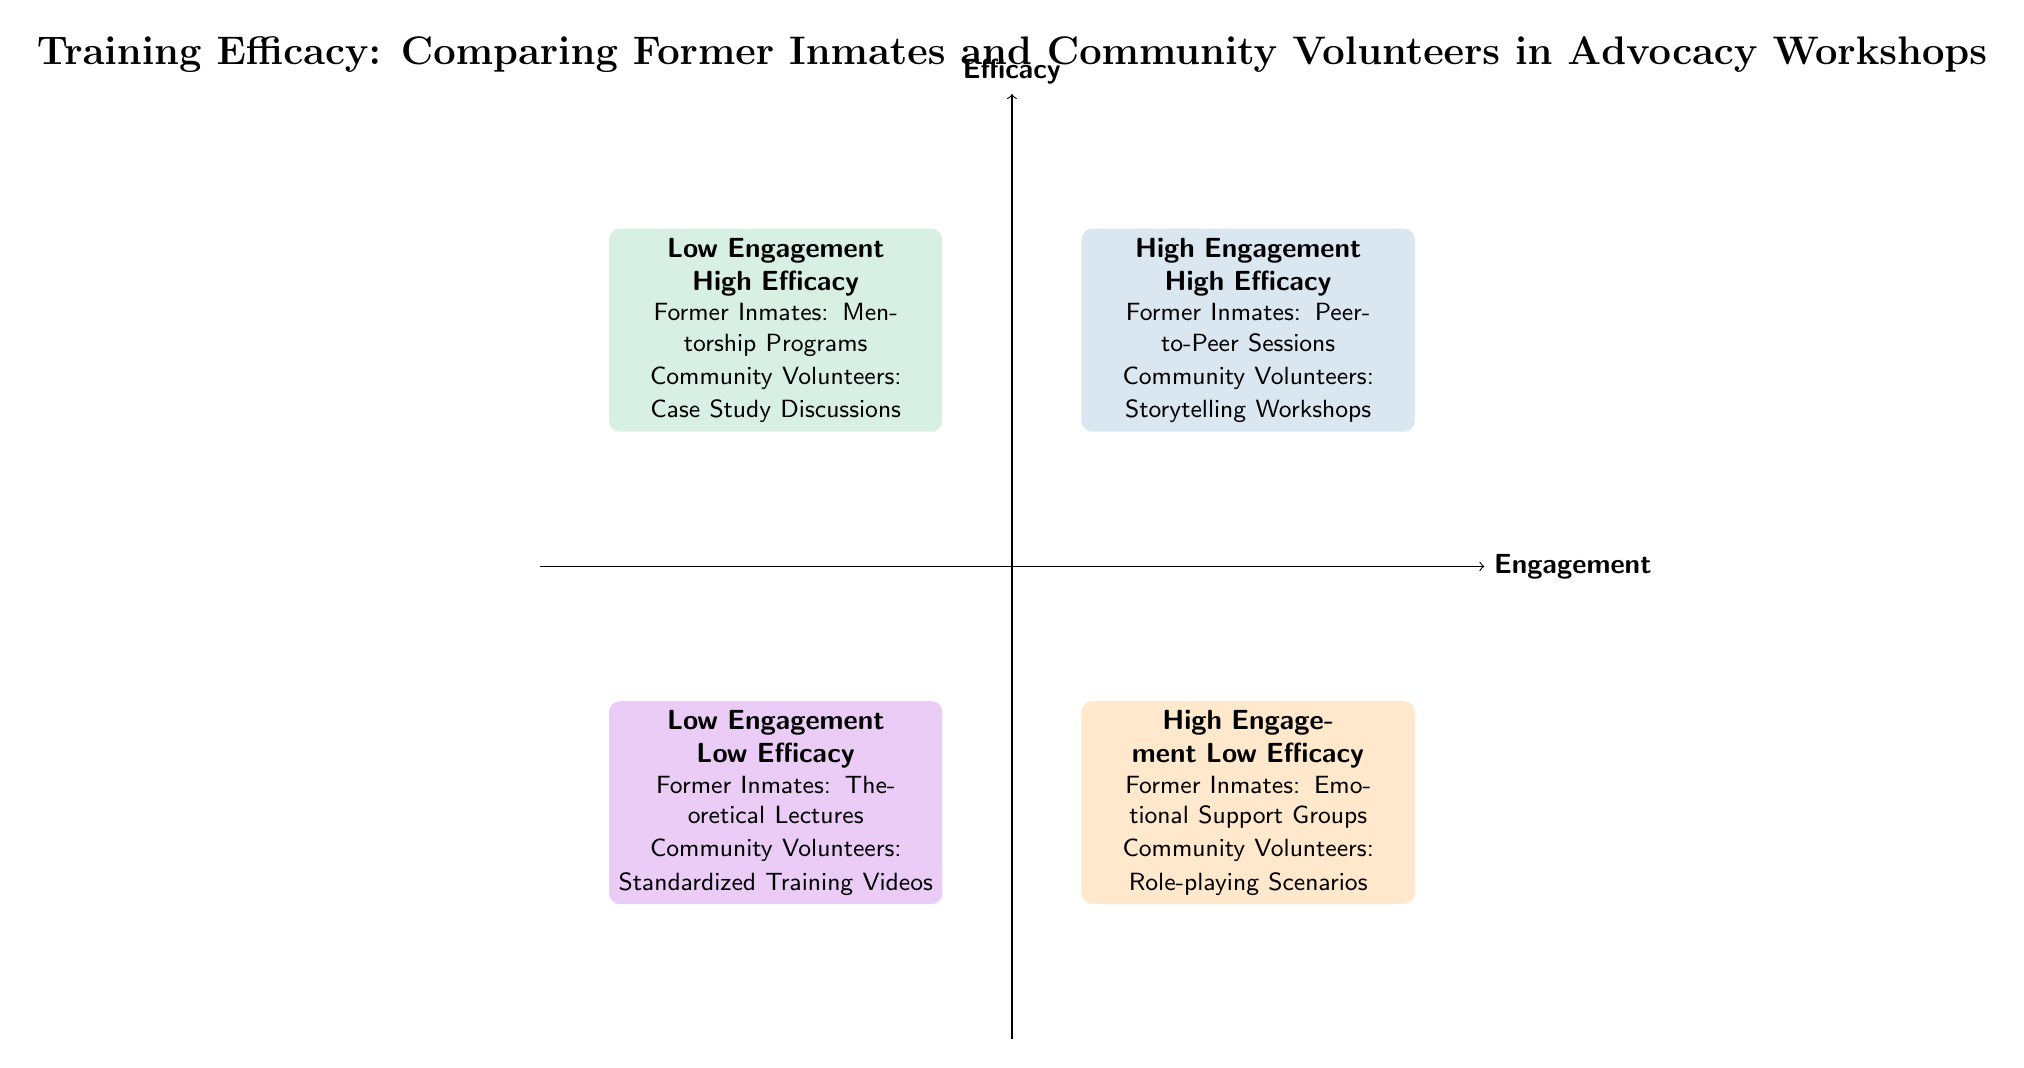What are the examples for High Engagement - High Efficacy? In Quadrant 1, titled "High Engagement - High Efficacy," the examples listed are "Former Inmates: Peer-to-Peer Sessions" and "Community Volunteers: Storytelling Workshops."
Answer: Former Inmates: Peer-to-Peer Sessions; Community Volunteers: Storytelling Workshops What quadrant is associated with Low Engagement - Low Efficacy? In Quadrant 3, which is labeled "Low Engagement - Low Efficacy," the examples provided are "Former Inmates: Theoretical Lectures" and "Community Volunteers: Standardized Training Videos."
Answer: Low Engagement - Low Efficacy How many quadrants are represented in the diagram? The diagram is divided into four distinct quadrants, representing various combinations of engagement and efficacy.
Answer: Four Which group is involved in High Engagement - Low Efficacy scenarios? In Quadrant 2, titled "High Engagement - Low Efficacy," the examples feature "Former Inmates: Emotional Support Groups" and "Community Volunteers: Role-playing Scenarios," indicating engagement but low efficacy.
Answer: Former Inmates; Community Volunteers What is the focus of the activities in the Low Engagement - High Efficacy quadrant? Quadrant 4, labeled "Low Engagement - High Efficacy," includes "Former Inmates: Mentorship Programs" and "Community Volunteers: Case Study Discussions," which highlights high efficacy despite low engagement.
Answer: Mentorship Programs; Case Study Discussions How do the examples differ between High Engagement - High Efficacy and Low Engagement - Low Efficacy? Quadrant 1 (High Engagement - High Efficacy) includes interactive sessions like "Peer-to-Peer Sessions," while Quadrant 3 (Low Engagement - Low Efficacy) features passive activities such as "Theoretical Lectures," indicating a contrast in engagement levels.
Answer: Interactive vs. Passive Activities What type of training does the former inmate group excel in according to the diagram? The diagram indicates that "Former Inmates: Peer-to-Peer Sessions" falls in the High Engagement - High Efficacy quadrant, showing their strength in effective engagement training.
Answer: Peer-to-Peer Sessions What is the distinction of activities in the High Engagement - Low Efficacy quadrant? Quadrant 2, titled "High Engagement - Low Efficacy," contains activities like "Emotional Support Groups" and "Role-playing Scenarios," indicating that while these activities are engaging, they do not achieve effective outcomes.
Answer: Engaging but Ineffective Activities 